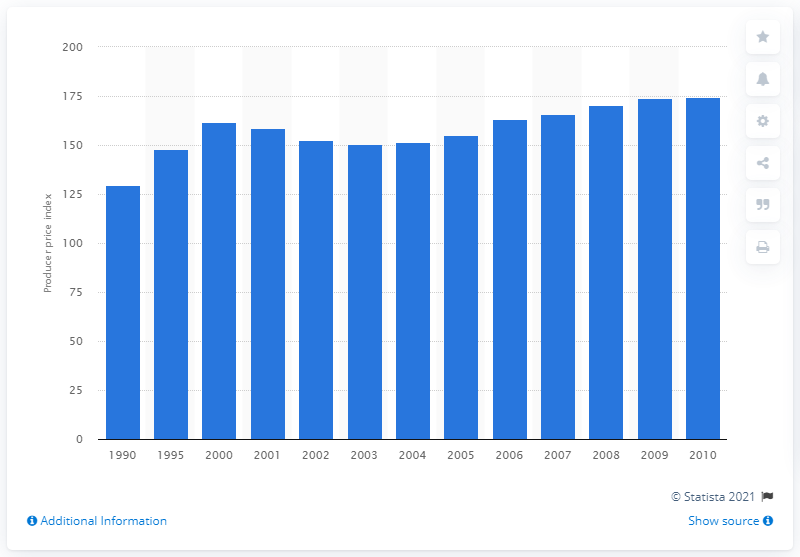List a handful of essential elements in this visual. In 2001, the producer price index for metal cutting machine tools was 158.8. 